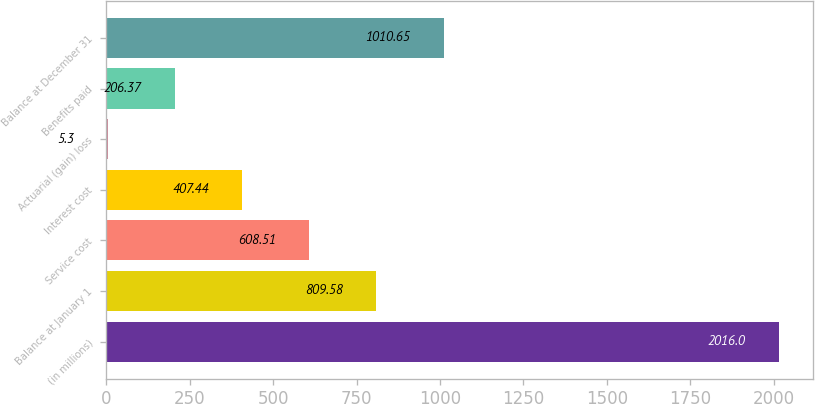Convert chart to OTSL. <chart><loc_0><loc_0><loc_500><loc_500><bar_chart><fcel>(in millions)<fcel>Balance at January 1<fcel>Service cost<fcel>Interest cost<fcel>Actuarial (gain) loss<fcel>Benefits paid<fcel>Balance at December 31<nl><fcel>2016<fcel>809.58<fcel>608.51<fcel>407.44<fcel>5.3<fcel>206.37<fcel>1010.65<nl></chart> 